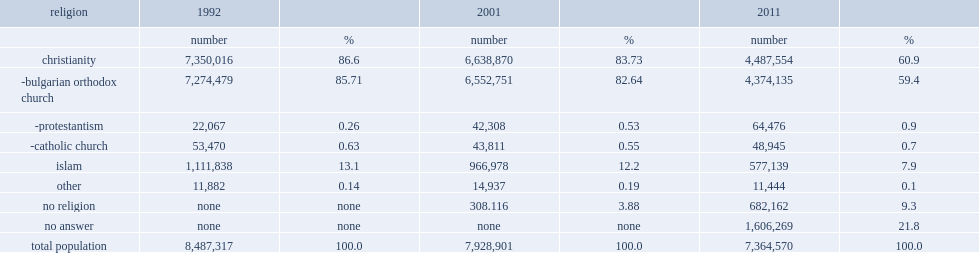According to the 2011 census, what percent of bulgarians did not respond to the question about religion? 21.8. 